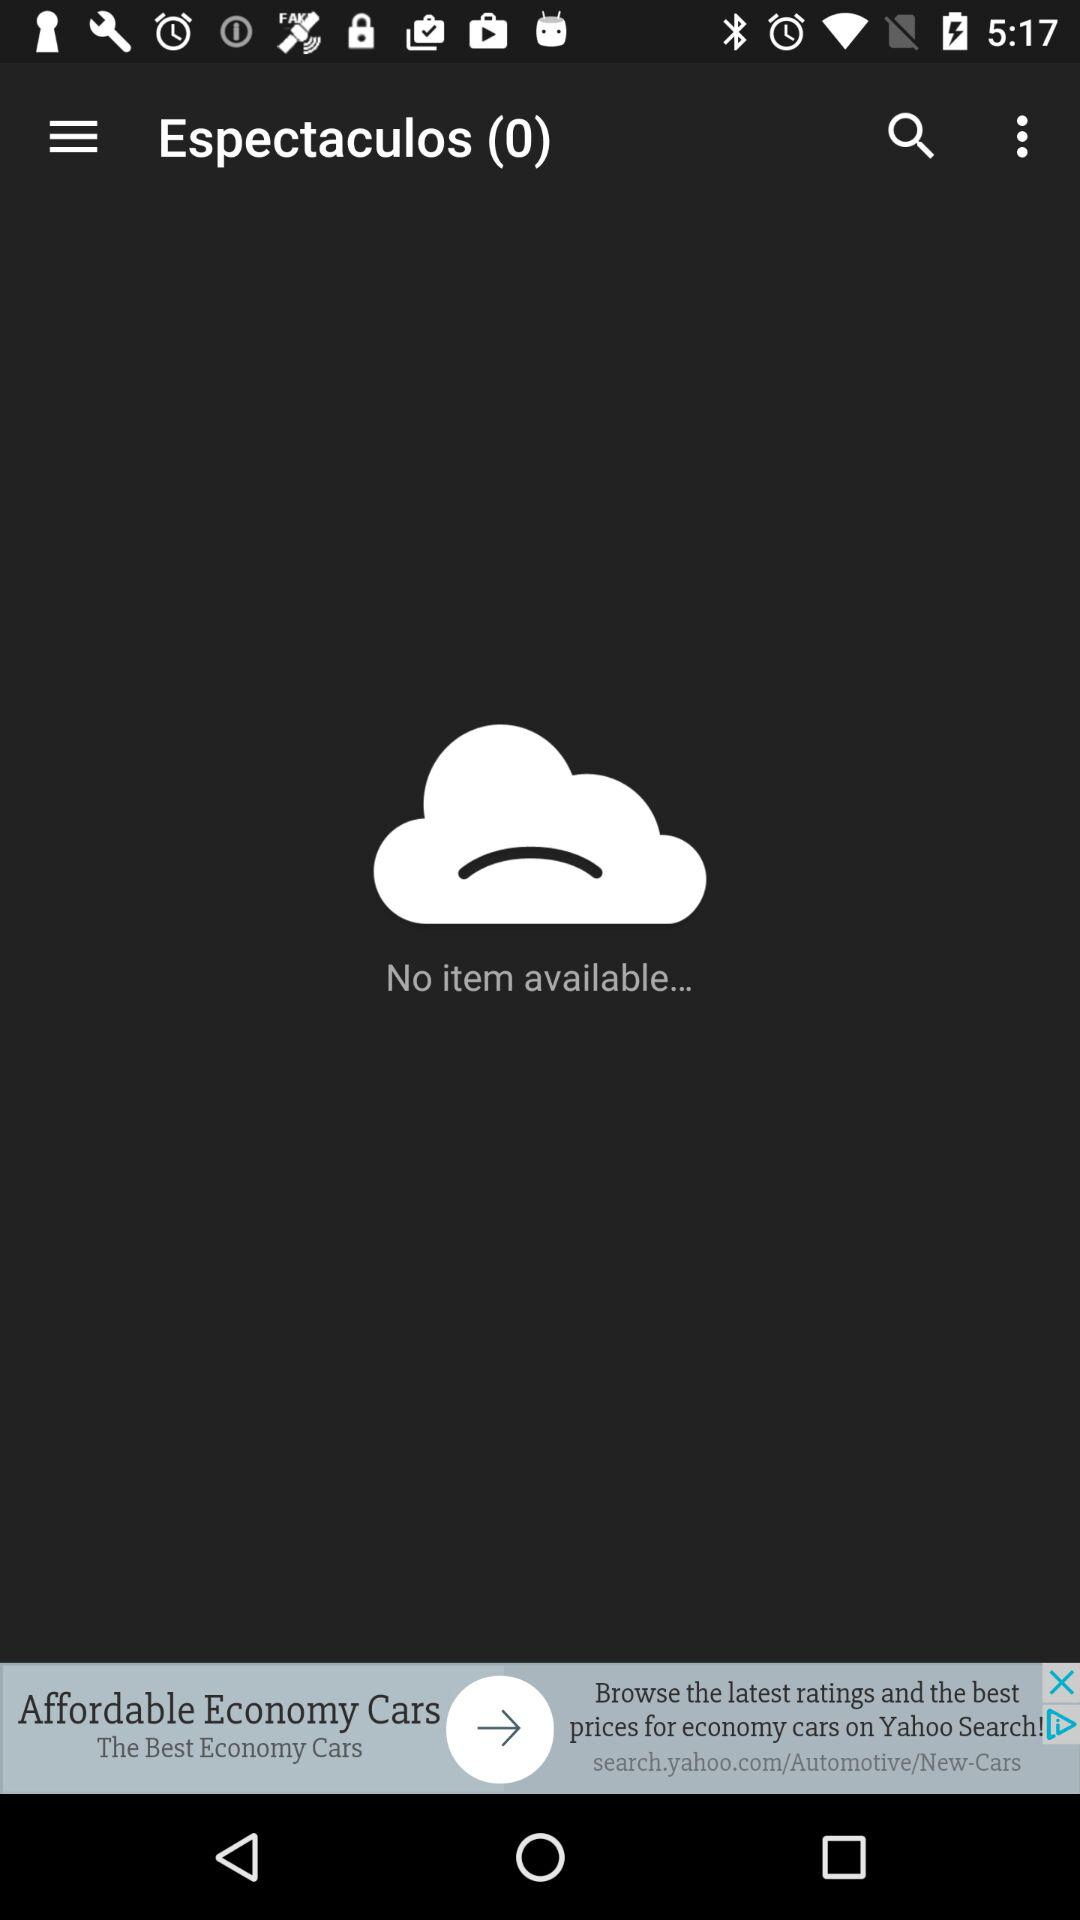Is there any item available on the screen? There is no item available on the screen. 